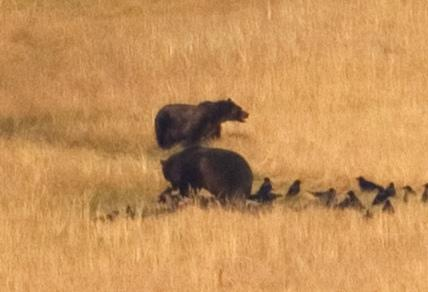Elaborate on the types of birds present in the field, and identify their positions. The field contains small, black birds and black ducks, some standing near the bears or scattered in various locations amidst the tall grass. Describe the key wildlife figures and their location within a field setting. The field is inhabited by bears and birds, with one black and one brown bear situated amongst the long grass, and black ducks and other birds dispersed throughout the scene. Create an image caption that highlights the key animals in the landscape. "Nature's Play: Bears and Birds Frolic in a Grassy Field Wonderland" Provide a brief description of the overall scene captured in the image. Bears and birds can be seen throughout a brown grassy field, with some animals standing or walking and others hidden behind the tall vegetation. Write a short scene overview that focuses on the main animals featured in the image. In a serene natural setting, a gentle dance between bears and birds unfolds amidst a network of tall, brown grass blanketing the picturesque field. Describe the environment and the main animals interacting within it. In a large field marked by tall brown grass and patches of green, bears and birds, including black ducks, roam and interact with one another. Summarize the contents and actions of the image in a single sentence. Bears and various birds coexist in a vast field characterized by brown tall grass and patches of green. Narrate the scene unfolding in the image. As the brown and black bears wander through the grassy field, small birds and black ducks fly and stroll around them, creating a lively scene. Mention the primary focal points of the image and their actions. Two bears, one brown and one black, appear amidst the tall grass, while several small birds and black ducks scatter around them in the field. State the main subjects in the image and how they seem to be interacting. Bears, including a brown and a black one, along with small, black birds and black ducks, are the central subjects, appearing to coexist calmly amidst the field's tall grass. 